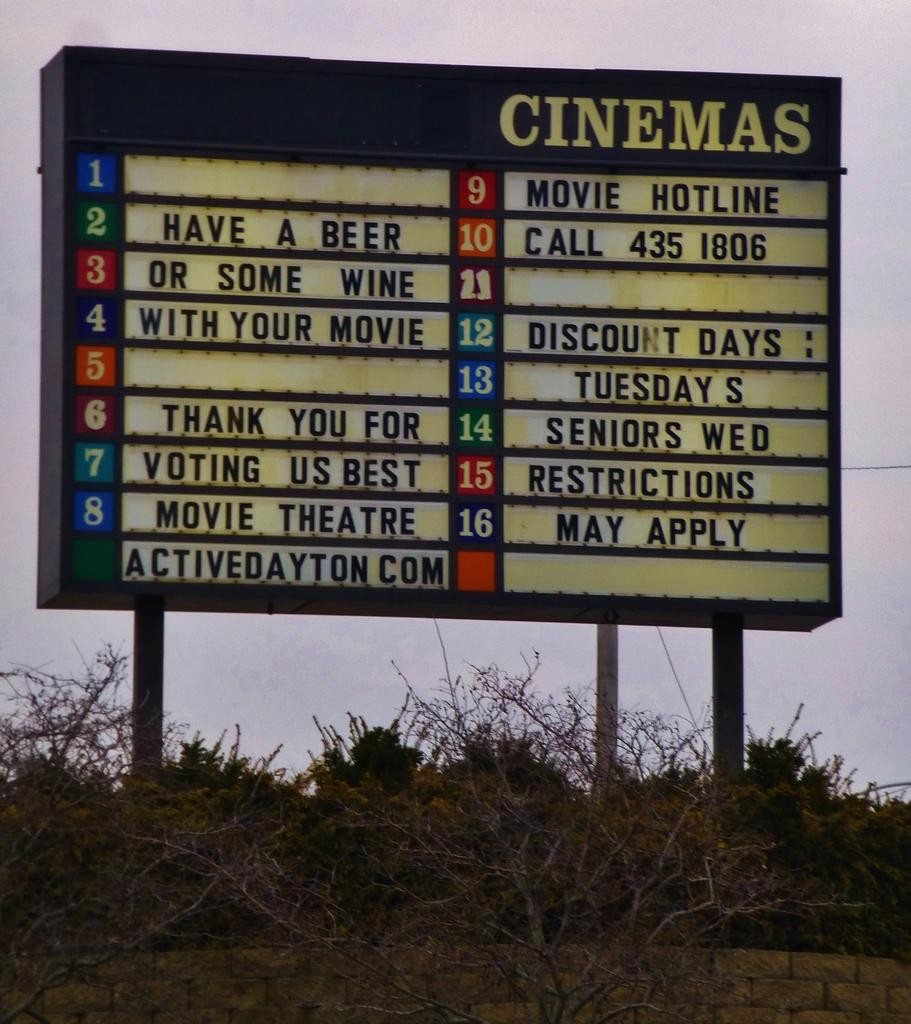Provide a one-sentence caption for the provided image. a signage with sayings, one reads HAVE A BEER OR SOME WINE WITH YOUR MOVIE. 